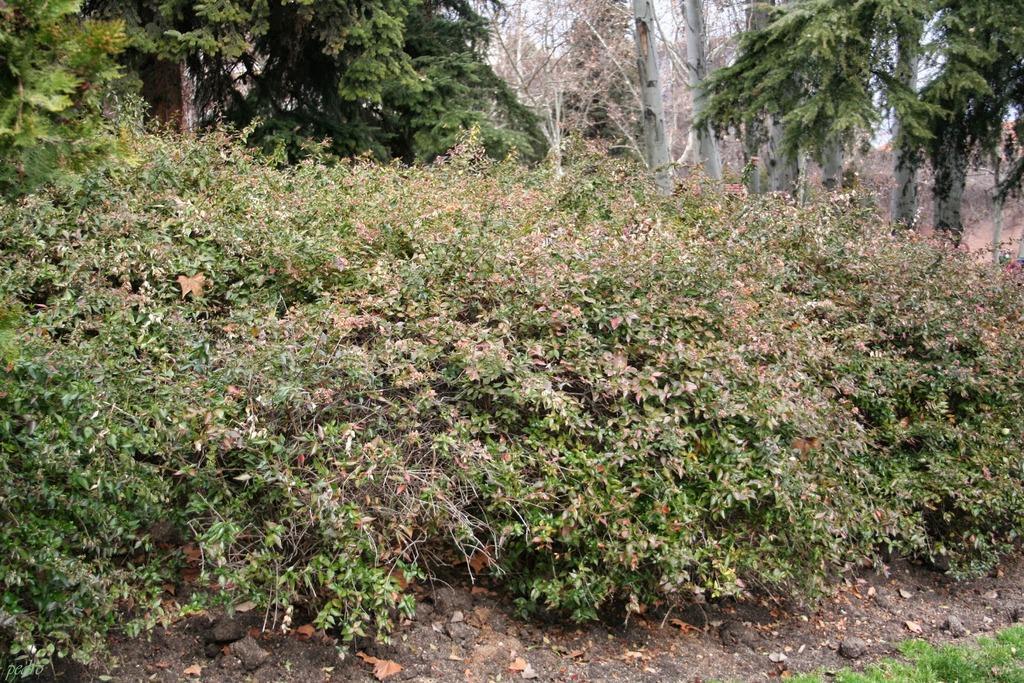Please provide a concise description of this image. In this image we can see plants, trees. At the bottom of the image there is soil and grass. 